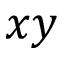Convert formula to latex. <formula><loc_0><loc_0><loc_500><loc_500>x y</formula> 